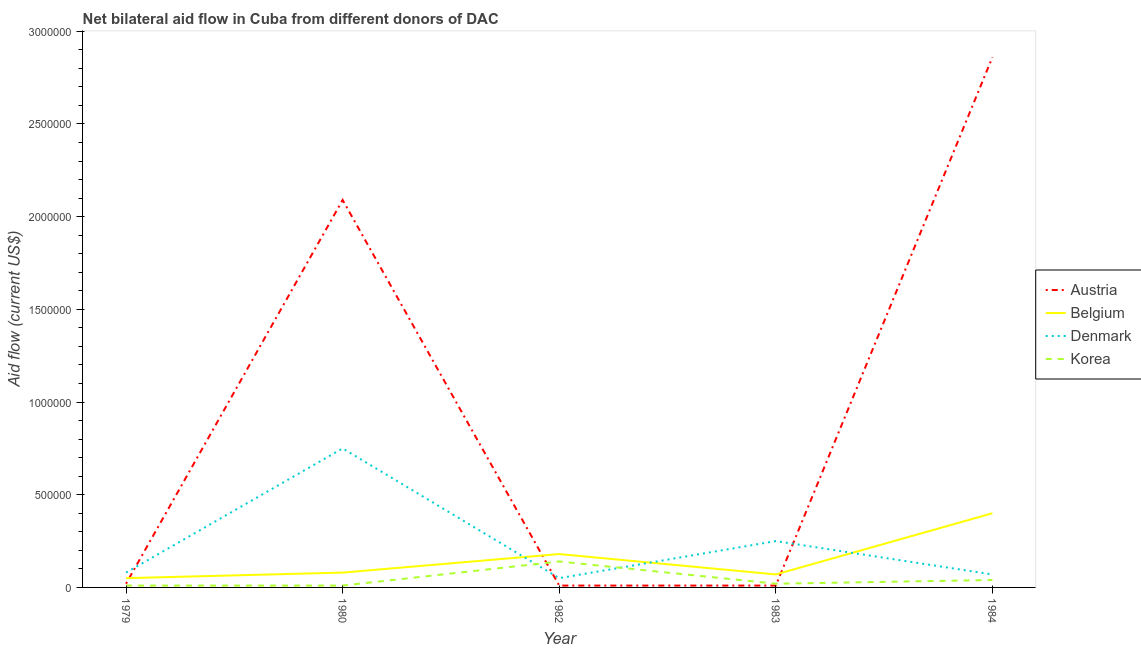How many different coloured lines are there?
Your answer should be compact. 4. Does the line corresponding to amount of aid given by belgium intersect with the line corresponding to amount of aid given by korea?
Make the answer very short. No. What is the amount of aid given by denmark in 1982?
Your response must be concise. 5.00e+04. Across all years, what is the maximum amount of aid given by korea?
Ensure brevity in your answer.  1.40e+05. Across all years, what is the minimum amount of aid given by korea?
Ensure brevity in your answer.  10000. What is the total amount of aid given by austria in the graph?
Provide a short and direct response. 4.99e+06. What is the difference between the amount of aid given by belgium in 1982 and that in 1984?
Provide a short and direct response. -2.20e+05. What is the difference between the amount of aid given by austria in 1984 and the amount of aid given by belgium in 1979?
Make the answer very short. 2.81e+06. What is the average amount of aid given by korea per year?
Offer a very short reply. 4.40e+04. In the year 1983, what is the difference between the amount of aid given by korea and amount of aid given by austria?
Make the answer very short. 10000. In how many years, is the amount of aid given by austria greater than 2000000 US$?
Make the answer very short. 2. What is the ratio of the amount of aid given by austria in 1979 to that in 1980?
Provide a short and direct response. 0.01. What is the difference between the highest and the second highest amount of aid given by denmark?
Ensure brevity in your answer.  5.00e+05. What is the difference between the highest and the lowest amount of aid given by denmark?
Keep it short and to the point. 7.00e+05. In how many years, is the amount of aid given by korea greater than the average amount of aid given by korea taken over all years?
Provide a succinct answer. 1. Is it the case that in every year, the sum of the amount of aid given by korea and amount of aid given by belgium is greater than the sum of amount of aid given by austria and amount of aid given by denmark?
Give a very brief answer. No. Is it the case that in every year, the sum of the amount of aid given by austria and amount of aid given by belgium is greater than the amount of aid given by denmark?
Your answer should be compact. No. Is the amount of aid given by belgium strictly less than the amount of aid given by korea over the years?
Provide a short and direct response. No. How many lines are there?
Provide a succinct answer. 4. How many years are there in the graph?
Your answer should be very brief. 5. Does the graph contain any zero values?
Your response must be concise. No. Where does the legend appear in the graph?
Keep it short and to the point. Center right. How are the legend labels stacked?
Your answer should be compact. Vertical. What is the title of the graph?
Offer a terse response. Net bilateral aid flow in Cuba from different donors of DAC. Does "Negligence towards children" appear as one of the legend labels in the graph?
Make the answer very short. No. What is the label or title of the Y-axis?
Provide a short and direct response. Aid flow (current US$). What is the Aid flow (current US$) of Belgium in 1979?
Your answer should be very brief. 5.00e+04. What is the Aid flow (current US$) in Denmark in 1979?
Provide a short and direct response. 8.00e+04. What is the Aid flow (current US$) in Korea in 1979?
Offer a very short reply. 10000. What is the Aid flow (current US$) in Austria in 1980?
Offer a very short reply. 2.09e+06. What is the Aid flow (current US$) of Belgium in 1980?
Give a very brief answer. 8.00e+04. What is the Aid flow (current US$) in Denmark in 1980?
Provide a succinct answer. 7.50e+05. What is the Aid flow (current US$) of Belgium in 1982?
Your answer should be very brief. 1.80e+05. What is the Aid flow (current US$) of Austria in 1983?
Offer a terse response. 10000. What is the Aid flow (current US$) of Korea in 1983?
Provide a short and direct response. 2.00e+04. What is the Aid flow (current US$) in Austria in 1984?
Offer a terse response. 2.86e+06. What is the Aid flow (current US$) of Belgium in 1984?
Your answer should be compact. 4.00e+05. What is the Aid flow (current US$) of Denmark in 1984?
Your response must be concise. 7.00e+04. What is the Aid flow (current US$) of Korea in 1984?
Make the answer very short. 4.00e+04. Across all years, what is the maximum Aid flow (current US$) in Austria?
Make the answer very short. 2.86e+06. Across all years, what is the maximum Aid flow (current US$) of Denmark?
Ensure brevity in your answer.  7.50e+05. Across all years, what is the minimum Aid flow (current US$) in Austria?
Your response must be concise. 10000. Across all years, what is the minimum Aid flow (current US$) in Belgium?
Offer a terse response. 5.00e+04. Across all years, what is the minimum Aid flow (current US$) of Korea?
Your answer should be very brief. 10000. What is the total Aid flow (current US$) of Austria in the graph?
Provide a short and direct response. 4.99e+06. What is the total Aid flow (current US$) of Belgium in the graph?
Keep it short and to the point. 7.80e+05. What is the total Aid flow (current US$) of Denmark in the graph?
Provide a succinct answer. 1.20e+06. What is the total Aid flow (current US$) of Korea in the graph?
Make the answer very short. 2.20e+05. What is the difference between the Aid flow (current US$) of Austria in 1979 and that in 1980?
Provide a short and direct response. -2.07e+06. What is the difference between the Aid flow (current US$) of Denmark in 1979 and that in 1980?
Make the answer very short. -6.70e+05. What is the difference between the Aid flow (current US$) of Korea in 1979 and that in 1980?
Offer a terse response. 0. What is the difference between the Aid flow (current US$) in Austria in 1979 and that in 1982?
Give a very brief answer. 10000. What is the difference between the Aid flow (current US$) in Belgium in 1979 and that in 1982?
Provide a succinct answer. -1.30e+05. What is the difference between the Aid flow (current US$) in Korea in 1979 and that in 1982?
Keep it short and to the point. -1.30e+05. What is the difference between the Aid flow (current US$) in Austria in 1979 and that in 1983?
Your answer should be compact. 10000. What is the difference between the Aid flow (current US$) in Belgium in 1979 and that in 1983?
Provide a short and direct response. -2.00e+04. What is the difference between the Aid flow (current US$) of Korea in 1979 and that in 1983?
Offer a terse response. -10000. What is the difference between the Aid flow (current US$) in Austria in 1979 and that in 1984?
Offer a very short reply. -2.84e+06. What is the difference between the Aid flow (current US$) in Belgium in 1979 and that in 1984?
Give a very brief answer. -3.50e+05. What is the difference between the Aid flow (current US$) of Denmark in 1979 and that in 1984?
Provide a short and direct response. 10000. What is the difference between the Aid flow (current US$) in Austria in 1980 and that in 1982?
Offer a very short reply. 2.08e+06. What is the difference between the Aid flow (current US$) in Denmark in 1980 and that in 1982?
Make the answer very short. 7.00e+05. What is the difference between the Aid flow (current US$) in Austria in 1980 and that in 1983?
Your answer should be compact. 2.08e+06. What is the difference between the Aid flow (current US$) of Korea in 1980 and that in 1983?
Give a very brief answer. -10000. What is the difference between the Aid flow (current US$) in Austria in 1980 and that in 1984?
Keep it short and to the point. -7.70e+05. What is the difference between the Aid flow (current US$) in Belgium in 1980 and that in 1984?
Your response must be concise. -3.20e+05. What is the difference between the Aid flow (current US$) in Denmark in 1980 and that in 1984?
Provide a succinct answer. 6.80e+05. What is the difference between the Aid flow (current US$) of Belgium in 1982 and that in 1983?
Make the answer very short. 1.10e+05. What is the difference between the Aid flow (current US$) in Denmark in 1982 and that in 1983?
Make the answer very short. -2.00e+05. What is the difference between the Aid flow (current US$) of Austria in 1982 and that in 1984?
Give a very brief answer. -2.85e+06. What is the difference between the Aid flow (current US$) of Denmark in 1982 and that in 1984?
Your answer should be very brief. -2.00e+04. What is the difference between the Aid flow (current US$) in Korea in 1982 and that in 1984?
Make the answer very short. 1.00e+05. What is the difference between the Aid flow (current US$) in Austria in 1983 and that in 1984?
Offer a terse response. -2.85e+06. What is the difference between the Aid flow (current US$) in Belgium in 1983 and that in 1984?
Give a very brief answer. -3.30e+05. What is the difference between the Aid flow (current US$) of Denmark in 1983 and that in 1984?
Your answer should be compact. 1.80e+05. What is the difference between the Aid flow (current US$) in Austria in 1979 and the Aid flow (current US$) in Belgium in 1980?
Give a very brief answer. -6.00e+04. What is the difference between the Aid flow (current US$) of Austria in 1979 and the Aid flow (current US$) of Denmark in 1980?
Keep it short and to the point. -7.30e+05. What is the difference between the Aid flow (current US$) in Belgium in 1979 and the Aid flow (current US$) in Denmark in 1980?
Ensure brevity in your answer.  -7.00e+05. What is the difference between the Aid flow (current US$) of Austria in 1979 and the Aid flow (current US$) of Denmark in 1982?
Offer a terse response. -3.00e+04. What is the difference between the Aid flow (current US$) in Belgium in 1979 and the Aid flow (current US$) in Denmark in 1982?
Provide a short and direct response. 0. What is the difference between the Aid flow (current US$) of Denmark in 1979 and the Aid flow (current US$) of Korea in 1982?
Provide a succinct answer. -6.00e+04. What is the difference between the Aid flow (current US$) of Austria in 1979 and the Aid flow (current US$) of Belgium in 1983?
Give a very brief answer. -5.00e+04. What is the difference between the Aid flow (current US$) of Austria in 1979 and the Aid flow (current US$) of Korea in 1983?
Ensure brevity in your answer.  0. What is the difference between the Aid flow (current US$) in Belgium in 1979 and the Aid flow (current US$) in Denmark in 1983?
Your response must be concise. -2.00e+05. What is the difference between the Aid flow (current US$) of Belgium in 1979 and the Aid flow (current US$) of Korea in 1983?
Provide a succinct answer. 3.00e+04. What is the difference between the Aid flow (current US$) in Denmark in 1979 and the Aid flow (current US$) in Korea in 1983?
Your answer should be very brief. 6.00e+04. What is the difference between the Aid flow (current US$) in Austria in 1979 and the Aid flow (current US$) in Belgium in 1984?
Keep it short and to the point. -3.80e+05. What is the difference between the Aid flow (current US$) in Austria in 1979 and the Aid flow (current US$) in Denmark in 1984?
Provide a short and direct response. -5.00e+04. What is the difference between the Aid flow (current US$) in Austria in 1979 and the Aid flow (current US$) in Korea in 1984?
Offer a very short reply. -2.00e+04. What is the difference between the Aid flow (current US$) of Belgium in 1979 and the Aid flow (current US$) of Denmark in 1984?
Ensure brevity in your answer.  -2.00e+04. What is the difference between the Aid flow (current US$) of Belgium in 1979 and the Aid flow (current US$) of Korea in 1984?
Your answer should be compact. 10000. What is the difference between the Aid flow (current US$) of Austria in 1980 and the Aid flow (current US$) of Belgium in 1982?
Offer a very short reply. 1.91e+06. What is the difference between the Aid flow (current US$) in Austria in 1980 and the Aid flow (current US$) in Denmark in 1982?
Your response must be concise. 2.04e+06. What is the difference between the Aid flow (current US$) of Austria in 1980 and the Aid flow (current US$) of Korea in 1982?
Keep it short and to the point. 1.95e+06. What is the difference between the Aid flow (current US$) in Belgium in 1980 and the Aid flow (current US$) in Denmark in 1982?
Ensure brevity in your answer.  3.00e+04. What is the difference between the Aid flow (current US$) of Austria in 1980 and the Aid flow (current US$) of Belgium in 1983?
Provide a succinct answer. 2.02e+06. What is the difference between the Aid flow (current US$) of Austria in 1980 and the Aid flow (current US$) of Denmark in 1983?
Your response must be concise. 1.84e+06. What is the difference between the Aid flow (current US$) in Austria in 1980 and the Aid flow (current US$) in Korea in 1983?
Offer a terse response. 2.07e+06. What is the difference between the Aid flow (current US$) of Belgium in 1980 and the Aid flow (current US$) of Denmark in 1983?
Offer a terse response. -1.70e+05. What is the difference between the Aid flow (current US$) of Denmark in 1980 and the Aid flow (current US$) of Korea in 1983?
Your answer should be compact. 7.30e+05. What is the difference between the Aid flow (current US$) in Austria in 1980 and the Aid flow (current US$) in Belgium in 1984?
Your response must be concise. 1.69e+06. What is the difference between the Aid flow (current US$) of Austria in 1980 and the Aid flow (current US$) of Denmark in 1984?
Ensure brevity in your answer.  2.02e+06. What is the difference between the Aid flow (current US$) in Austria in 1980 and the Aid flow (current US$) in Korea in 1984?
Your response must be concise. 2.05e+06. What is the difference between the Aid flow (current US$) in Denmark in 1980 and the Aid flow (current US$) in Korea in 1984?
Provide a succinct answer. 7.10e+05. What is the difference between the Aid flow (current US$) in Austria in 1982 and the Aid flow (current US$) in Belgium in 1983?
Your answer should be compact. -6.00e+04. What is the difference between the Aid flow (current US$) in Austria in 1982 and the Aid flow (current US$) in Denmark in 1983?
Your response must be concise. -2.40e+05. What is the difference between the Aid flow (current US$) of Austria in 1982 and the Aid flow (current US$) of Korea in 1983?
Provide a short and direct response. -10000. What is the difference between the Aid flow (current US$) of Austria in 1982 and the Aid flow (current US$) of Belgium in 1984?
Give a very brief answer. -3.90e+05. What is the difference between the Aid flow (current US$) of Belgium in 1982 and the Aid flow (current US$) of Denmark in 1984?
Keep it short and to the point. 1.10e+05. What is the difference between the Aid flow (current US$) of Belgium in 1982 and the Aid flow (current US$) of Korea in 1984?
Ensure brevity in your answer.  1.40e+05. What is the difference between the Aid flow (current US$) of Denmark in 1982 and the Aid flow (current US$) of Korea in 1984?
Give a very brief answer. 10000. What is the difference between the Aid flow (current US$) of Austria in 1983 and the Aid flow (current US$) of Belgium in 1984?
Provide a succinct answer. -3.90e+05. What is the difference between the Aid flow (current US$) of Austria in 1983 and the Aid flow (current US$) of Denmark in 1984?
Give a very brief answer. -6.00e+04. What is the difference between the Aid flow (current US$) in Belgium in 1983 and the Aid flow (current US$) in Denmark in 1984?
Your response must be concise. 0. What is the difference between the Aid flow (current US$) of Belgium in 1983 and the Aid flow (current US$) of Korea in 1984?
Your answer should be compact. 3.00e+04. What is the difference between the Aid flow (current US$) of Denmark in 1983 and the Aid flow (current US$) of Korea in 1984?
Provide a short and direct response. 2.10e+05. What is the average Aid flow (current US$) in Austria per year?
Provide a succinct answer. 9.98e+05. What is the average Aid flow (current US$) of Belgium per year?
Your answer should be very brief. 1.56e+05. What is the average Aid flow (current US$) in Korea per year?
Ensure brevity in your answer.  4.40e+04. In the year 1979, what is the difference between the Aid flow (current US$) in Austria and Aid flow (current US$) in Denmark?
Your answer should be compact. -6.00e+04. In the year 1979, what is the difference between the Aid flow (current US$) in Denmark and Aid flow (current US$) in Korea?
Your answer should be compact. 7.00e+04. In the year 1980, what is the difference between the Aid flow (current US$) in Austria and Aid flow (current US$) in Belgium?
Make the answer very short. 2.01e+06. In the year 1980, what is the difference between the Aid flow (current US$) in Austria and Aid flow (current US$) in Denmark?
Your answer should be very brief. 1.34e+06. In the year 1980, what is the difference between the Aid flow (current US$) of Austria and Aid flow (current US$) of Korea?
Your answer should be compact. 2.08e+06. In the year 1980, what is the difference between the Aid flow (current US$) in Belgium and Aid flow (current US$) in Denmark?
Your answer should be compact. -6.70e+05. In the year 1980, what is the difference between the Aid flow (current US$) in Belgium and Aid flow (current US$) in Korea?
Give a very brief answer. 7.00e+04. In the year 1980, what is the difference between the Aid flow (current US$) in Denmark and Aid flow (current US$) in Korea?
Your answer should be compact. 7.40e+05. In the year 1982, what is the difference between the Aid flow (current US$) in Austria and Aid flow (current US$) in Belgium?
Provide a short and direct response. -1.70e+05. In the year 1982, what is the difference between the Aid flow (current US$) in Austria and Aid flow (current US$) in Denmark?
Keep it short and to the point. -4.00e+04. In the year 1982, what is the difference between the Aid flow (current US$) in Belgium and Aid flow (current US$) in Korea?
Your answer should be compact. 4.00e+04. In the year 1983, what is the difference between the Aid flow (current US$) of Austria and Aid flow (current US$) of Denmark?
Offer a terse response. -2.40e+05. In the year 1984, what is the difference between the Aid flow (current US$) of Austria and Aid flow (current US$) of Belgium?
Make the answer very short. 2.46e+06. In the year 1984, what is the difference between the Aid flow (current US$) in Austria and Aid flow (current US$) in Denmark?
Offer a terse response. 2.79e+06. In the year 1984, what is the difference between the Aid flow (current US$) in Austria and Aid flow (current US$) in Korea?
Ensure brevity in your answer.  2.82e+06. What is the ratio of the Aid flow (current US$) in Austria in 1979 to that in 1980?
Your answer should be compact. 0.01. What is the ratio of the Aid flow (current US$) in Belgium in 1979 to that in 1980?
Provide a succinct answer. 0.62. What is the ratio of the Aid flow (current US$) of Denmark in 1979 to that in 1980?
Your answer should be compact. 0.11. What is the ratio of the Aid flow (current US$) of Korea in 1979 to that in 1980?
Offer a very short reply. 1. What is the ratio of the Aid flow (current US$) of Belgium in 1979 to that in 1982?
Offer a terse response. 0.28. What is the ratio of the Aid flow (current US$) of Korea in 1979 to that in 1982?
Your answer should be very brief. 0.07. What is the ratio of the Aid flow (current US$) of Denmark in 1979 to that in 1983?
Offer a terse response. 0.32. What is the ratio of the Aid flow (current US$) of Austria in 1979 to that in 1984?
Your answer should be very brief. 0.01. What is the ratio of the Aid flow (current US$) of Belgium in 1979 to that in 1984?
Provide a short and direct response. 0.12. What is the ratio of the Aid flow (current US$) of Denmark in 1979 to that in 1984?
Keep it short and to the point. 1.14. What is the ratio of the Aid flow (current US$) in Austria in 1980 to that in 1982?
Offer a very short reply. 209. What is the ratio of the Aid flow (current US$) in Belgium in 1980 to that in 1982?
Give a very brief answer. 0.44. What is the ratio of the Aid flow (current US$) in Denmark in 1980 to that in 1982?
Provide a succinct answer. 15. What is the ratio of the Aid flow (current US$) of Korea in 1980 to that in 1982?
Offer a terse response. 0.07. What is the ratio of the Aid flow (current US$) in Austria in 1980 to that in 1983?
Your answer should be very brief. 209. What is the ratio of the Aid flow (current US$) of Denmark in 1980 to that in 1983?
Make the answer very short. 3. What is the ratio of the Aid flow (current US$) in Austria in 1980 to that in 1984?
Give a very brief answer. 0.73. What is the ratio of the Aid flow (current US$) in Belgium in 1980 to that in 1984?
Offer a very short reply. 0.2. What is the ratio of the Aid flow (current US$) in Denmark in 1980 to that in 1984?
Offer a very short reply. 10.71. What is the ratio of the Aid flow (current US$) in Korea in 1980 to that in 1984?
Provide a succinct answer. 0.25. What is the ratio of the Aid flow (current US$) of Belgium in 1982 to that in 1983?
Offer a terse response. 2.57. What is the ratio of the Aid flow (current US$) in Austria in 1982 to that in 1984?
Your answer should be very brief. 0. What is the ratio of the Aid flow (current US$) in Belgium in 1982 to that in 1984?
Your response must be concise. 0.45. What is the ratio of the Aid flow (current US$) in Korea in 1982 to that in 1984?
Your answer should be compact. 3.5. What is the ratio of the Aid flow (current US$) of Austria in 1983 to that in 1984?
Your response must be concise. 0. What is the ratio of the Aid flow (current US$) of Belgium in 1983 to that in 1984?
Make the answer very short. 0.17. What is the ratio of the Aid flow (current US$) in Denmark in 1983 to that in 1984?
Ensure brevity in your answer.  3.57. What is the difference between the highest and the second highest Aid flow (current US$) in Austria?
Your answer should be compact. 7.70e+05. What is the difference between the highest and the second highest Aid flow (current US$) of Belgium?
Offer a very short reply. 2.20e+05. What is the difference between the highest and the second highest Aid flow (current US$) of Denmark?
Offer a terse response. 5.00e+05. What is the difference between the highest and the second highest Aid flow (current US$) of Korea?
Your response must be concise. 1.00e+05. What is the difference between the highest and the lowest Aid flow (current US$) of Austria?
Your answer should be very brief. 2.85e+06. What is the difference between the highest and the lowest Aid flow (current US$) of Belgium?
Offer a terse response. 3.50e+05. What is the difference between the highest and the lowest Aid flow (current US$) of Denmark?
Offer a terse response. 7.00e+05. What is the difference between the highest and the lowest Aid flow (current US$) of Korea?
Provide a succinct answer. 1.30e+05. 